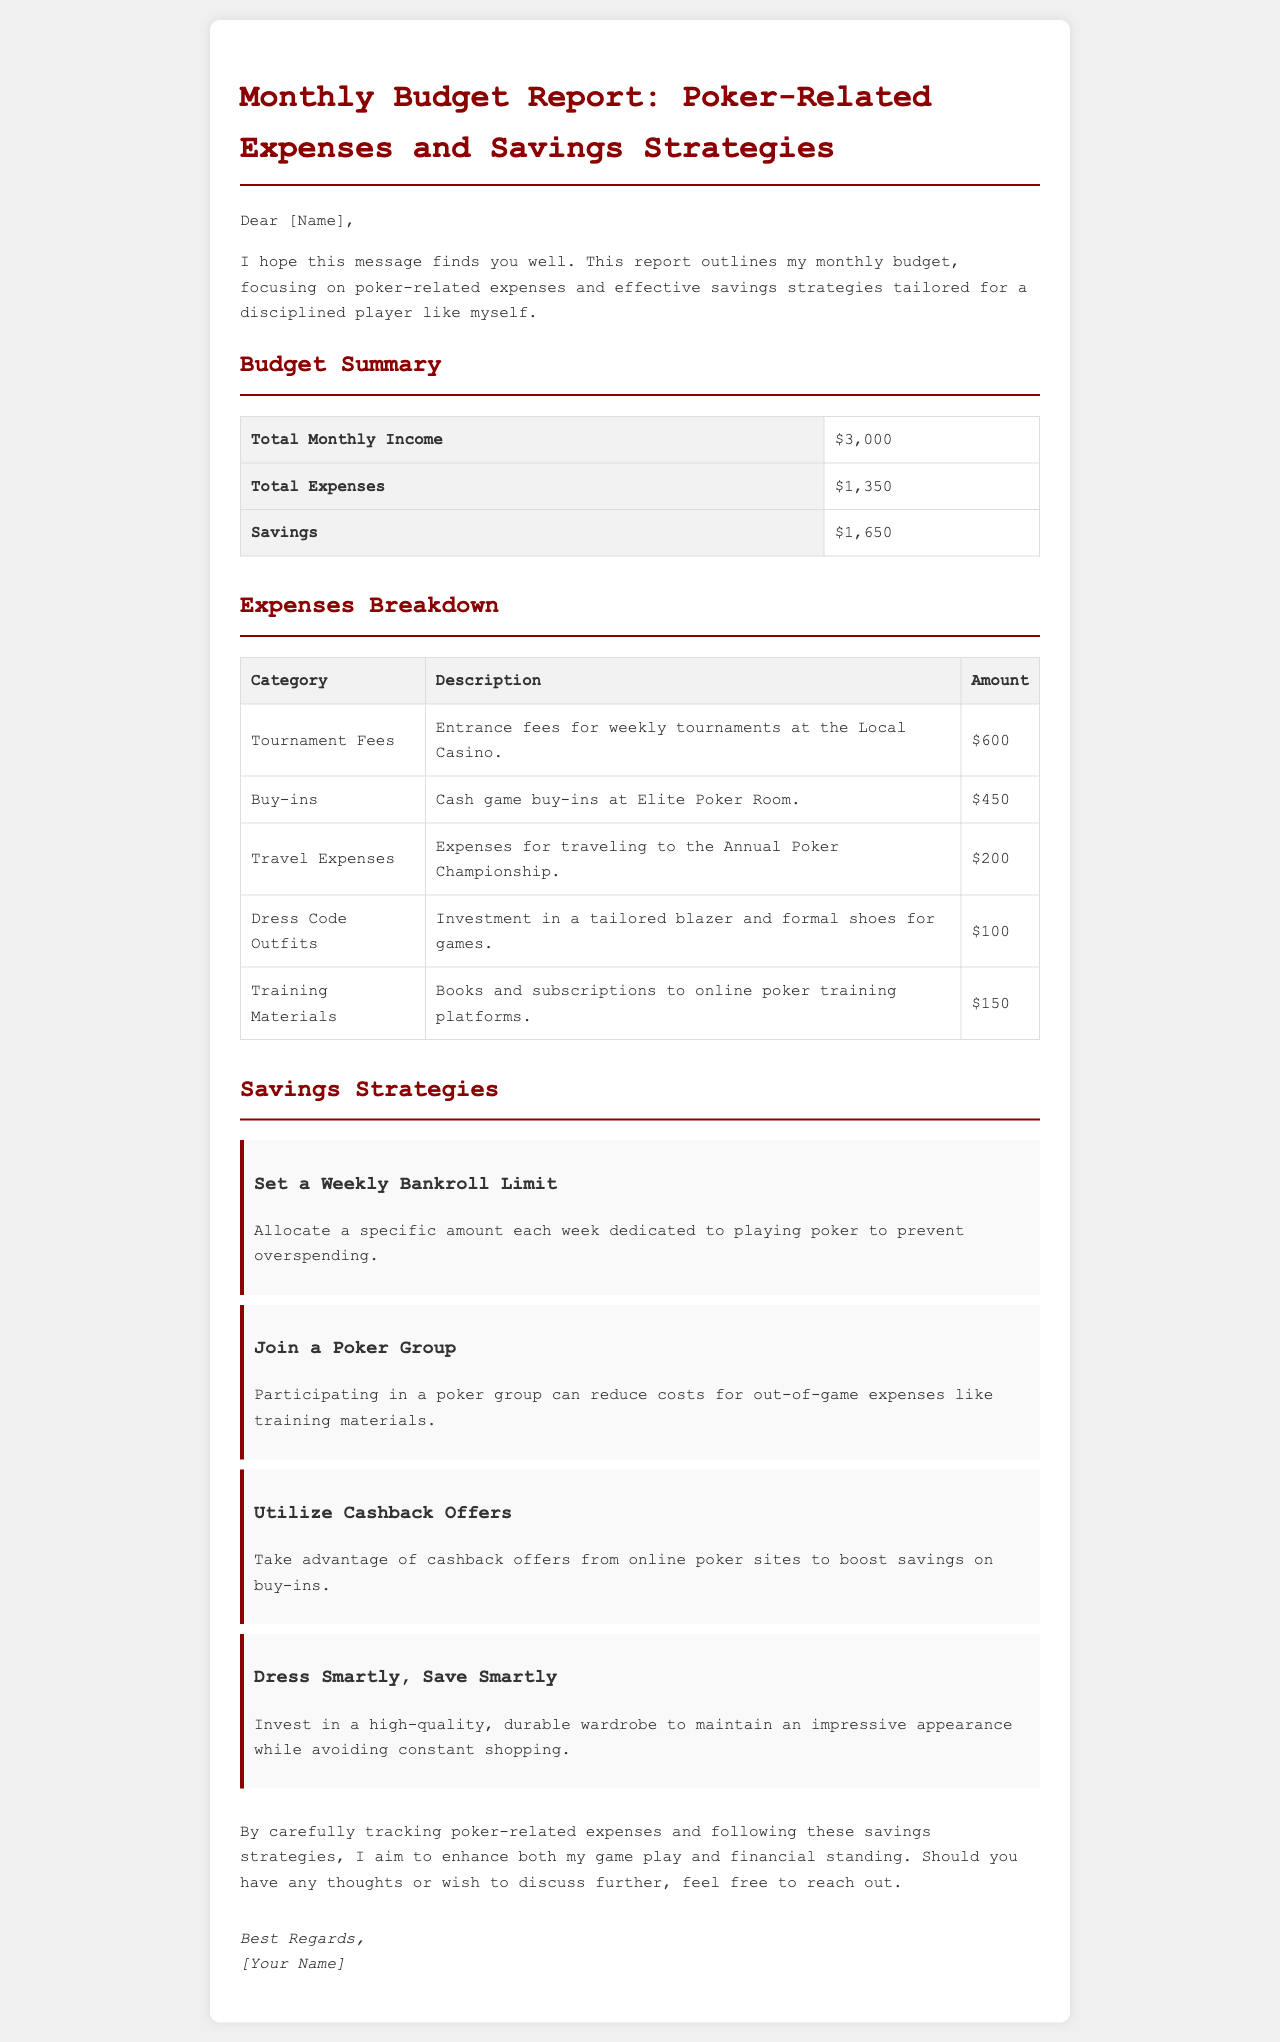What is the total monthly income? The total monthly income is stated clearly in the budget summary section of the document.
Answer: $3,000 How much was spent on tournament fees? The amount spent on tournament fees is detailed in the expenses breakdown table.
Answer: $600 What is the total amount saved this month? The savings section indicates the total amount saved, which is derived from the budget summary.
Answer: $1,650 What percentage of the total income was spent on buy-ins? To determine the percentage spent on buy-ins, we relate the buy-ins amount to the total monthly income.
Answer: 15% What is one savings strategy mentioned in the report? The document lists several strategies, one of which contributors can easily recall.
Answer: Set a Weekly Bankroll Limit How much was spent on dress code outfits? The expense for dress code outfits is specified in the expenses breakdown.
Answer: $100 What were the travel expenses for? The travel expenses are outlined in the expenses breakdown, giving a specific context.
Answer: Annual Poker Championship Which type of expenses does the budget report focus on? The report centers on poker-related expenses, highlighting their relevance in the monthly budget.
Answer: Poker-related expenses How does one strategy suggest reducing costs for training materials? The report indicates that participating in a poker group can offer substantial savings in this area.
Answer: Join a Poker Group What is the main purpose of this email? The email aims to provide a clear budget report detailing expenses and savings strategies for poker.
Answer: Monthly budget report 